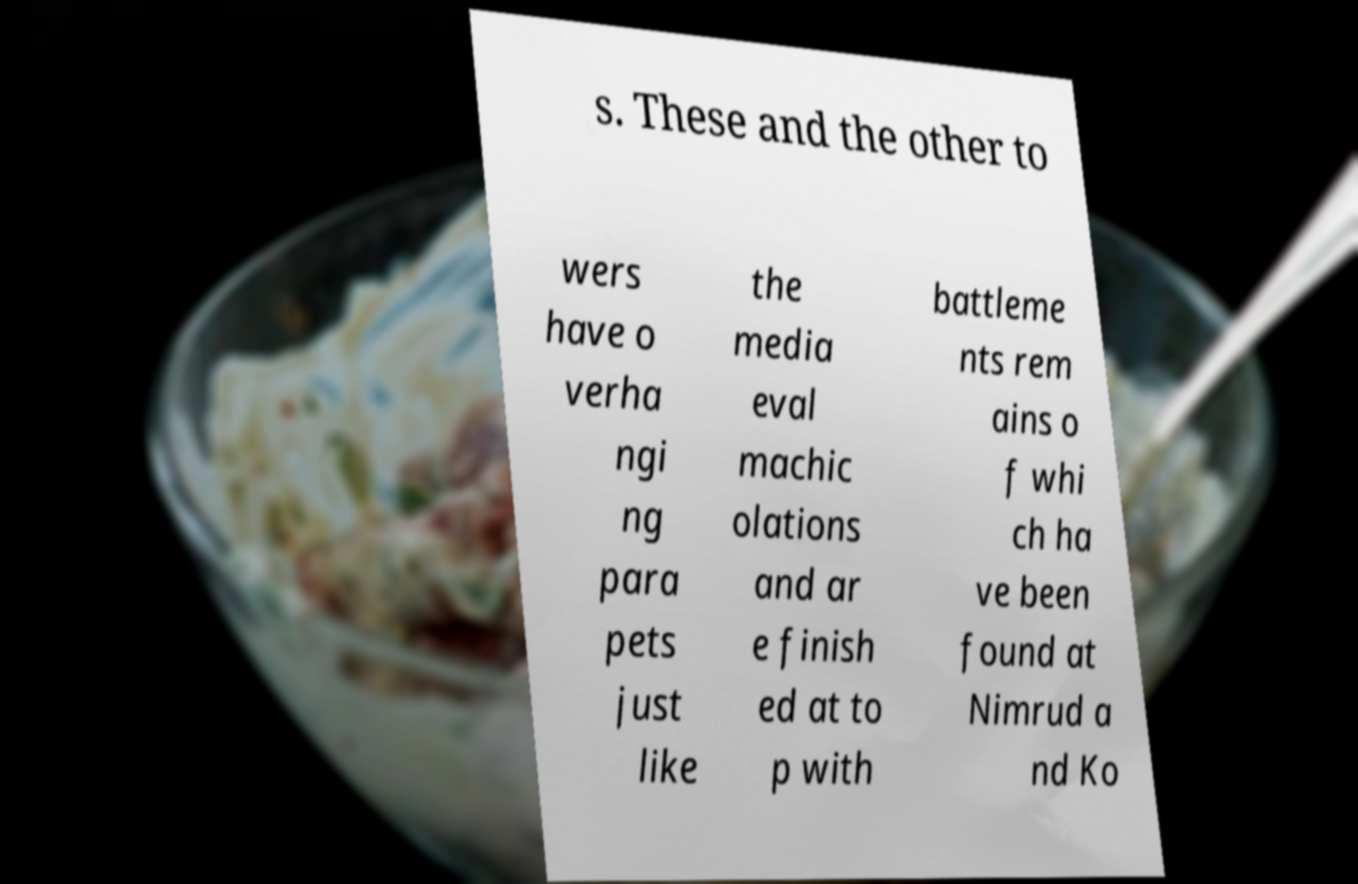Please read and relay the text visible in this image. What does it say? s. These and the other to wers have o verha ngi ng para pets just like the media eval machic olations and ar e finish ed at to p with battleme nts rem ains o f whi ch ha ve been found at Nimrud a nd Ko 